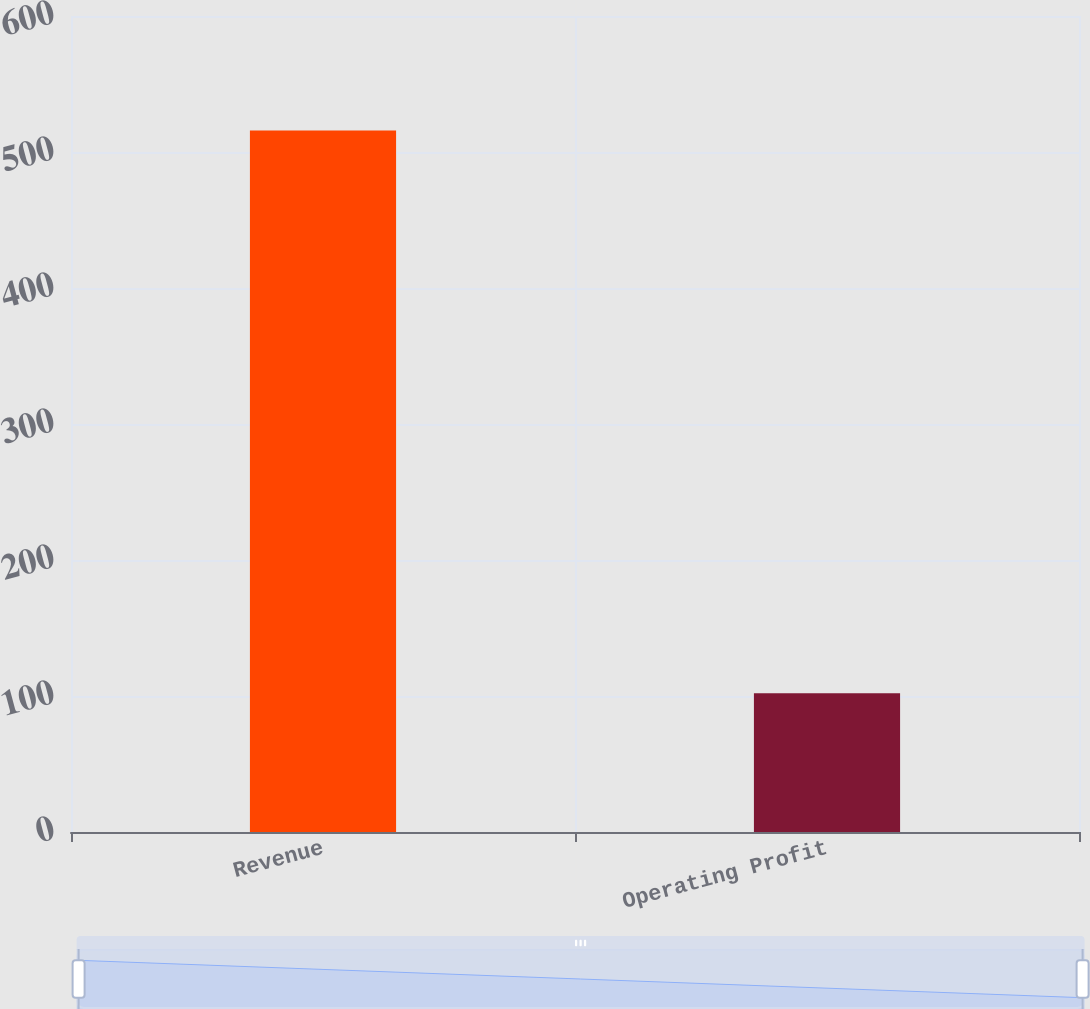Convert chart to OTSL. <chart><loc_0><loc_0><loc_500><loc_500><bar_chart><fcel>Revenue<fcel>Operating Profit<nl><fcel>515.8<fcel>102.1<nl></chart> 